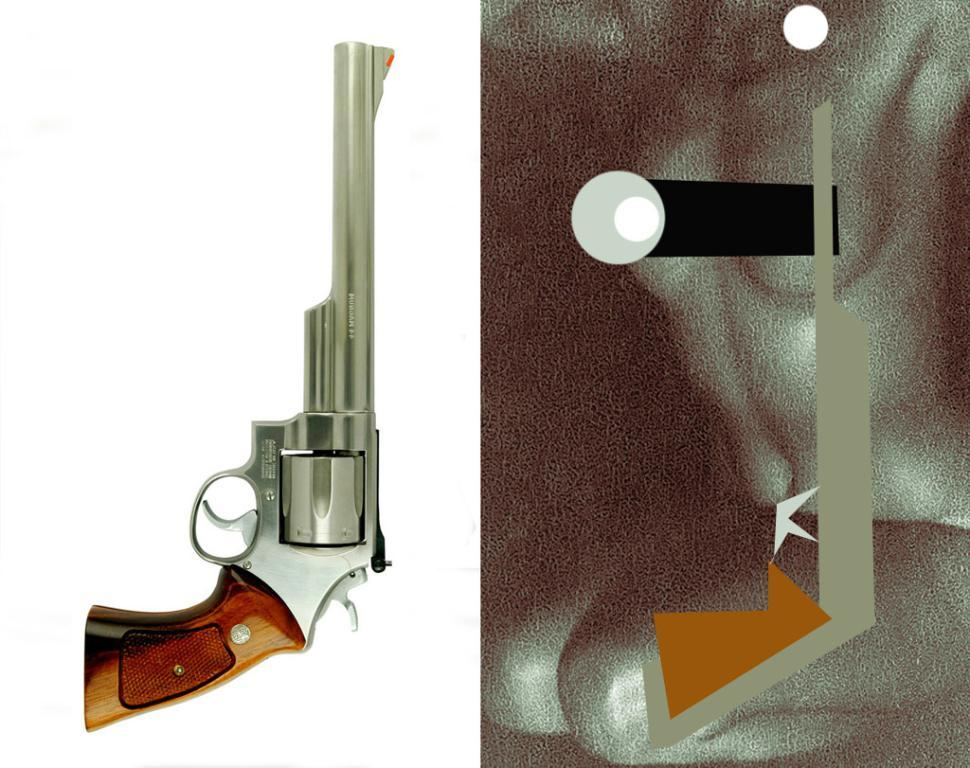What type of picture is in the image? There is a collage picture in the image. What object is present in the collage picture? There is a gun in the image. How can you tell that the gun is present in the collage? The outline of the gun is visible in the image. What colors are used for the background of the image? The background of the image is in white and black color. How many basketballs are visible in the image? There are no basketballs present in the image. What angle is the gun held at in the image? The image is a collage, and the gun is not being held by anyone, so there is no angle to consider. 